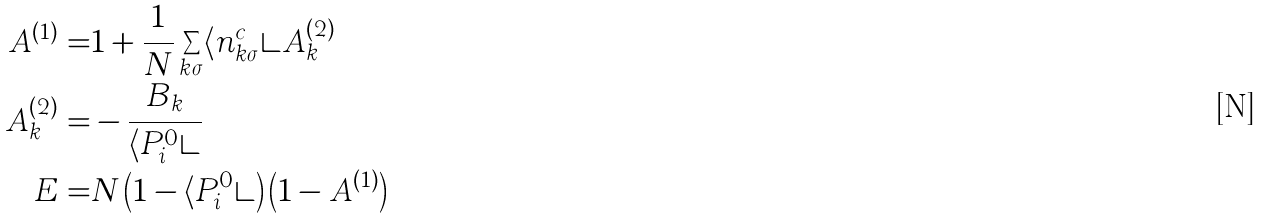Convert formula to latex. <formula><loc_0><loc_0><loc_500><loc_500>A ^ { ( 1 ) } = & 1 + \frac { 1 } { N } \sum _ { k \sigma } \langle n _ { k \sigma } ^ { c } \rangle A _ { k } ^ { ( 2 ) } \\ A _ { k } ^ { ( 2 ) } = & - \frac { B _ { k } } { \langle P _ { i } ^ { 0 } \rangle } \\ E = & N \left ( 1 - \langle P _ { i } ^ { 0 } \rangle \right ) \left ( 1 - A ^ { ( 1 ) } \right )</formula> 